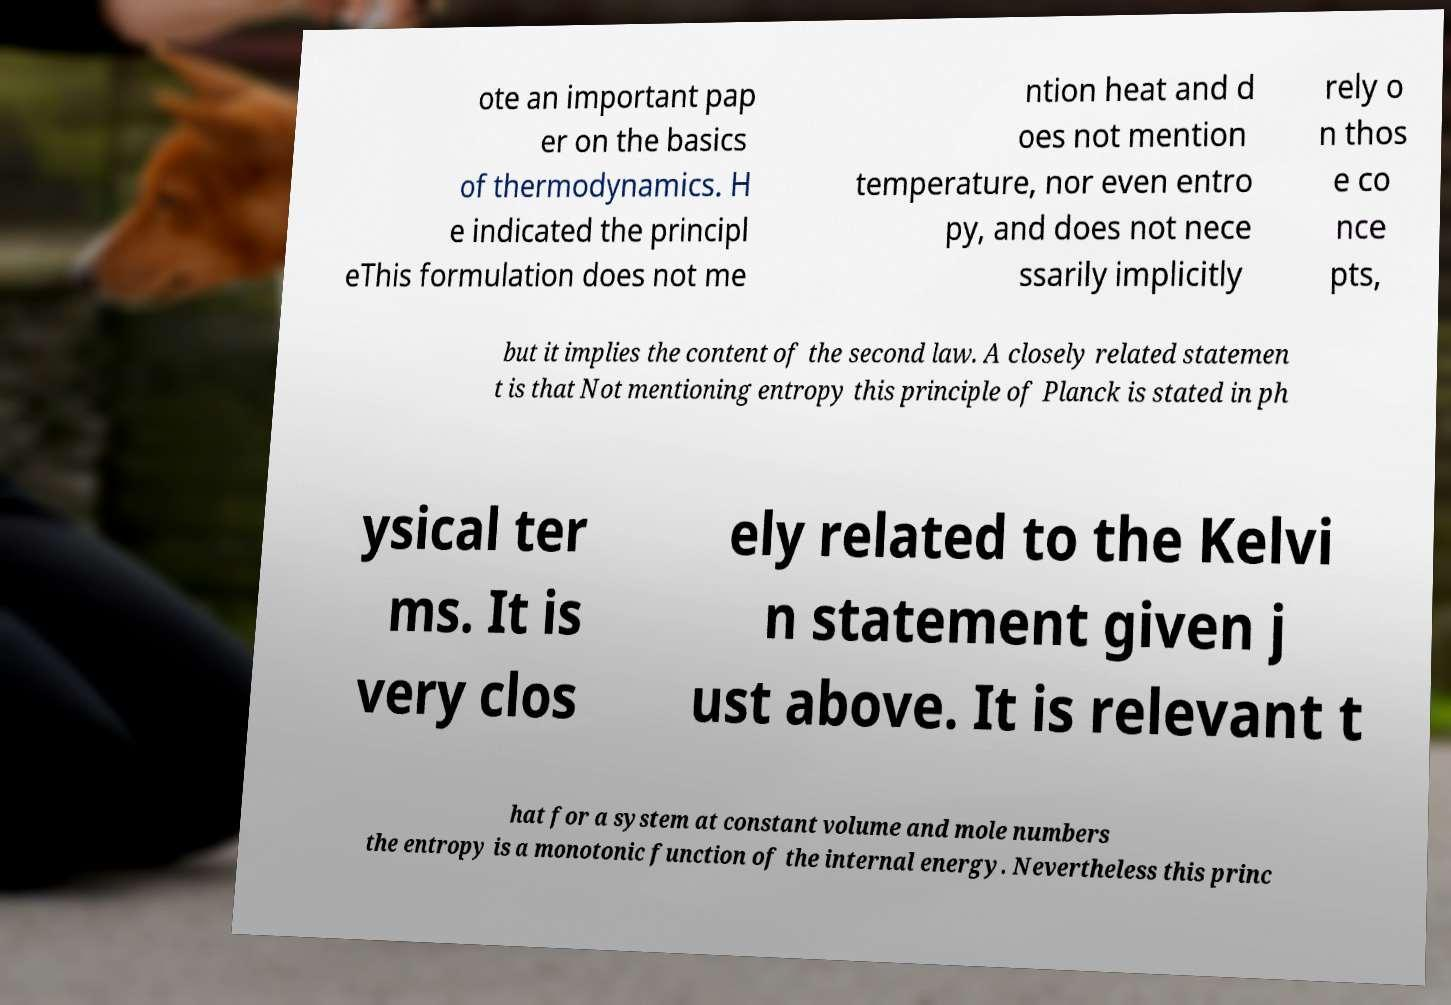I need the written content from this picture converted into text. Can you do that? ote an important pap er on the basics of thermodynamics. H e indicated the principl eThis formulation does not me ntion heat and d oes not mention temperature, nor even entro py, and does not nece ssarily implicitly rely o n thos e co nce pts, but it implies the content of the second law. A closely related statemen t is that Not mentioning entropy this principle of Planck is stated in ph ysical ter ms. It is very clos ely related to the Kelvi n statement given j ust above. It is relevant t hat for a system at constant volume and mole numbers the entropy is a monotonic function of the internal energy. Nevertheless this princ 